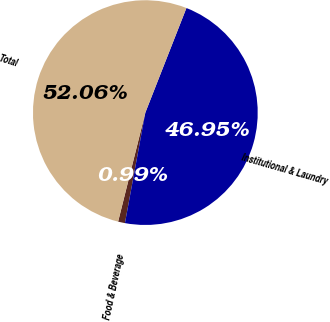Convert chart. <chart><loc_0><loc_0><loc_500><loc_500><pie_chart><fcel>Food & Beverage<fcel>Institutional & Laundry<fcel>Total<nl><fcel>0.99%<fcel>46.95%<fcel>52.06%<nl></chart> 